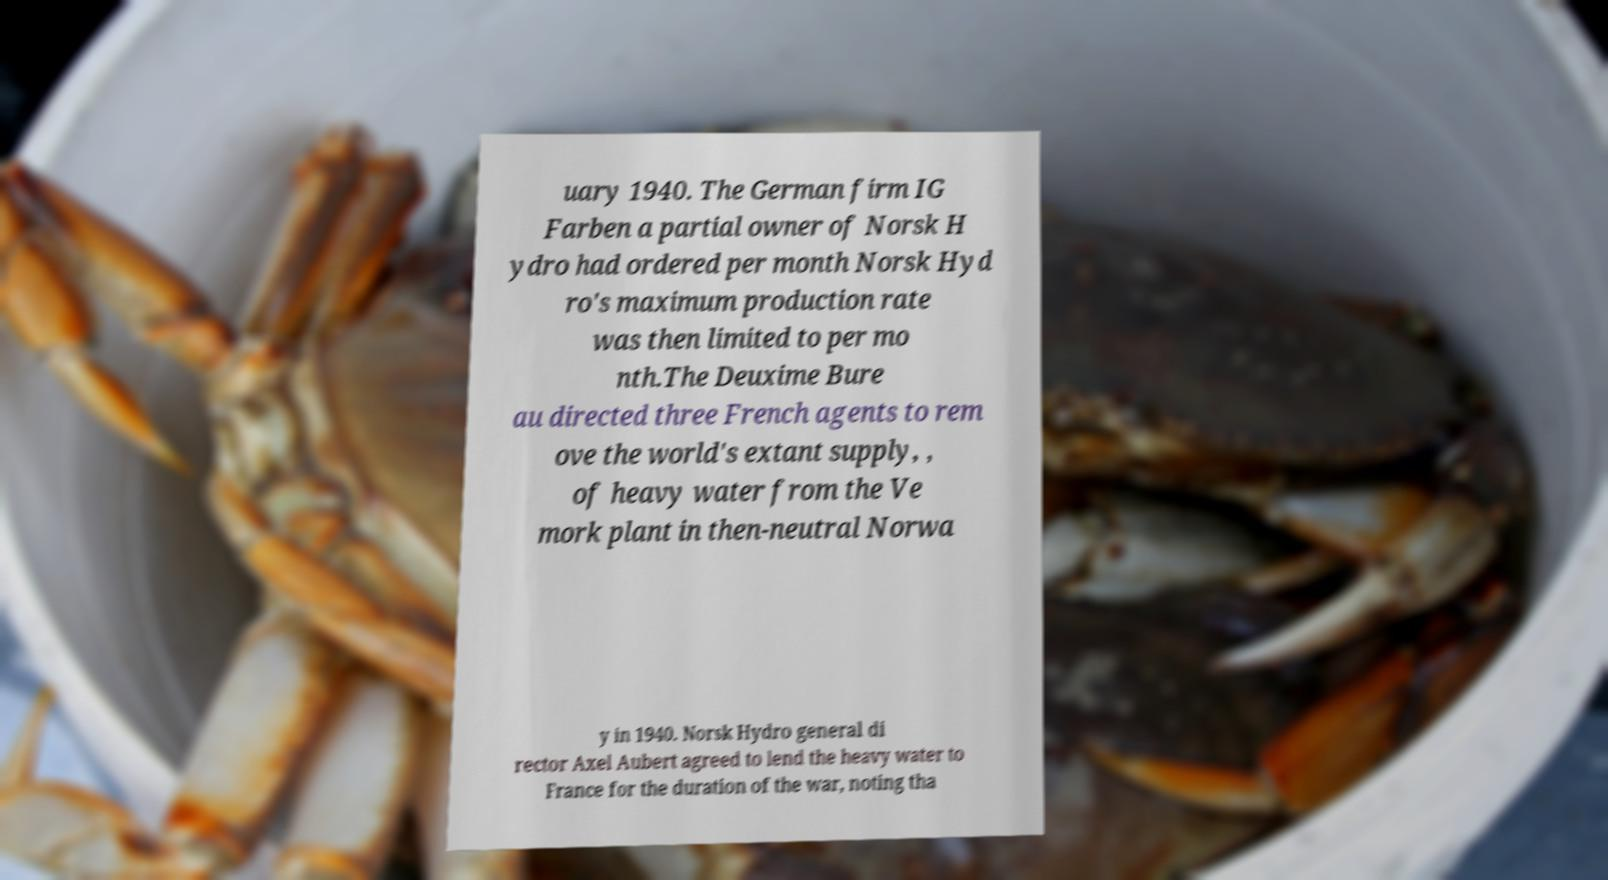There's text embedded in this image that I need extracted. Can you transcribe it verbatim? uary 1940. The German firm IG Farben a partial owner of Norsk H ydro had ordered per month Norsk Hyd ro's maximum production rate was then limited to per mo nth.The Deuxime Bure au directed three French agents to rem ove the world's extant supply, , of heavy water from the Ve mork plant in then-neutral Norwa y in 1940. Norsk Hydro general di rector Axel Aubert agreed to lend the heavy water to France for the duration of the war, noting tha 